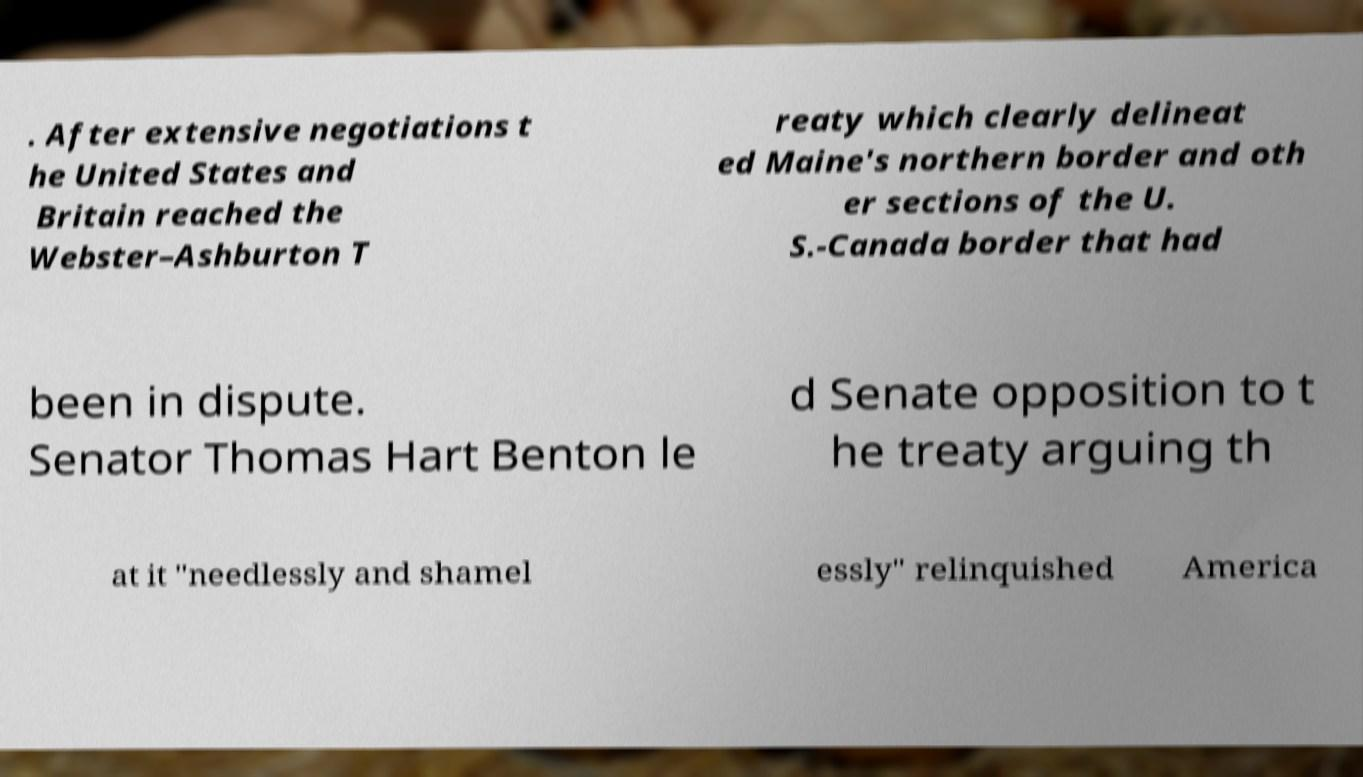What messages or text are displayed in this image? I need them in a readable, typed format. . After extensive negotiations t he United States and Britain reached the Webster–Ashburton T reaty which clearly delineat ed Maine's northern border and oth er sections of the U. S.-Canada border that had been in dispute. Senator Thomas Hart Benton le d Senate opposition to t he treaty arguing th at it "needlessly and shamel essly" relinquished America 